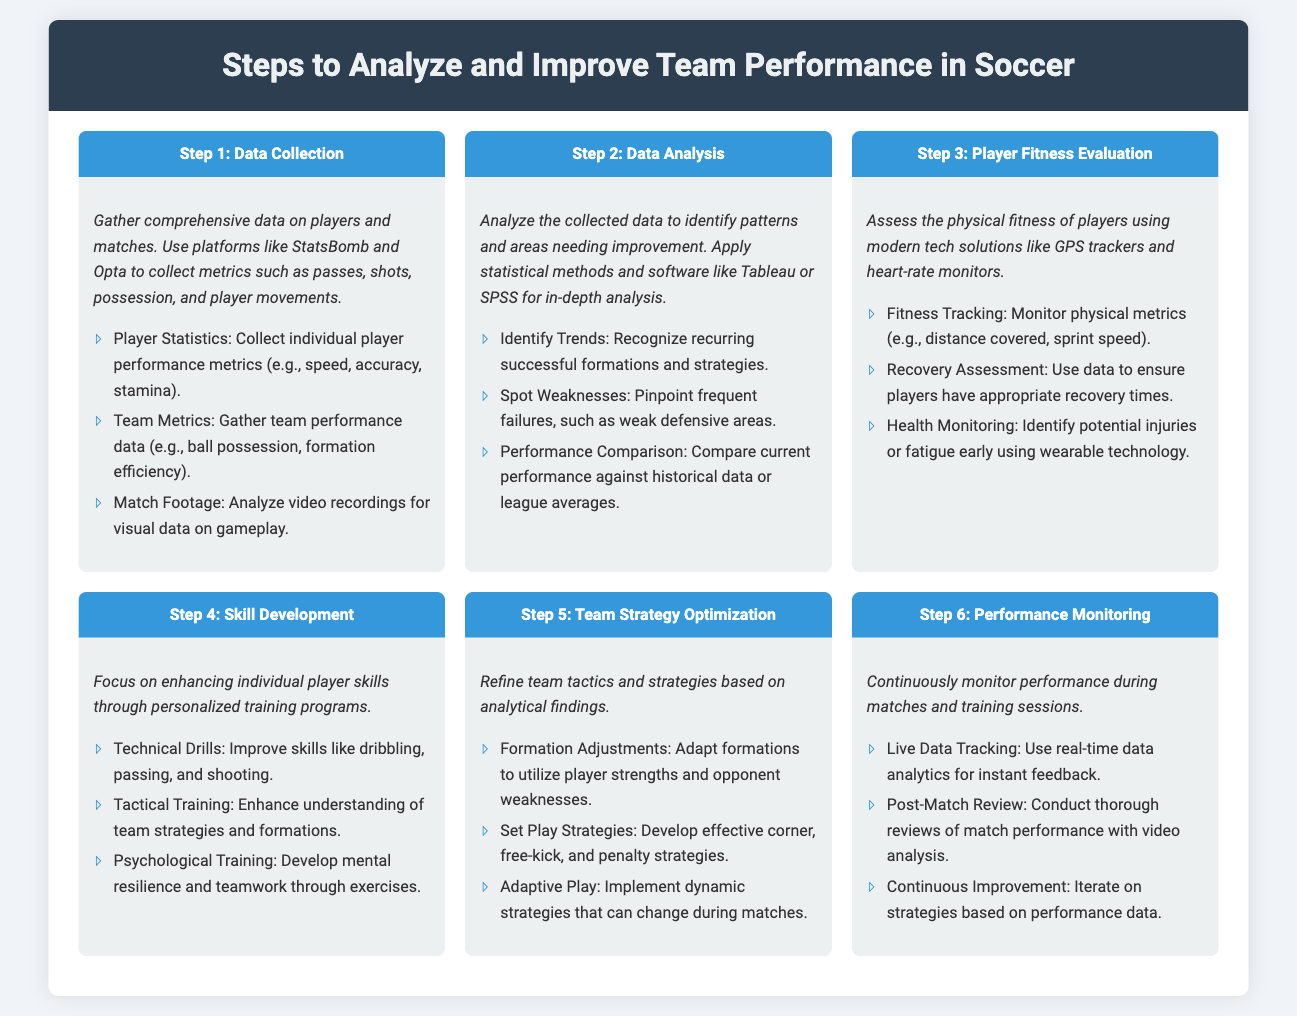What is the first step in analyzing team performance? The first step listed in the document for analyzing team performance is "Data Collection."
Answer: Data Collection What is one method mentioned for data analysis? The document suggests using "Tableau" or "SPSS" for in-depth data analysis.
Answer: Tableau or SPSS How should player fitness be evaluated? Player fitness should be evaluated using "GPS trackers and heart-rate monitors."
Answer: GPS trackers and heart-rate monitors What is the emphasis of Step 4? Step 4 focuses on enhancing individual player skills through "personalized training programs."
Answer: Personalized training programs Which step involves continuous monitoring? The last step, Step 6, involves "Performance Monitoring."
Answer: Performance Monitoring How many sub-steps are there under Step 3? Step 3 includes three sub-steps: fitness tracking, recovery assessment, and health monitoring.
Answer: Three What should be adapted according to player strengths? The document states that "formation adjustments" should be made to utilize player strengths.
Answer: Formation adjustments What is the goal of tactical training? The goal of tactical training is to enhance understanding of "team strategies and formations."
Answer: Team strategies and formations What technology helps in early injury detection? The document mentions using "wearable technology" for early injury detection and fatigue monitoring.
Answer: Wearable technology 